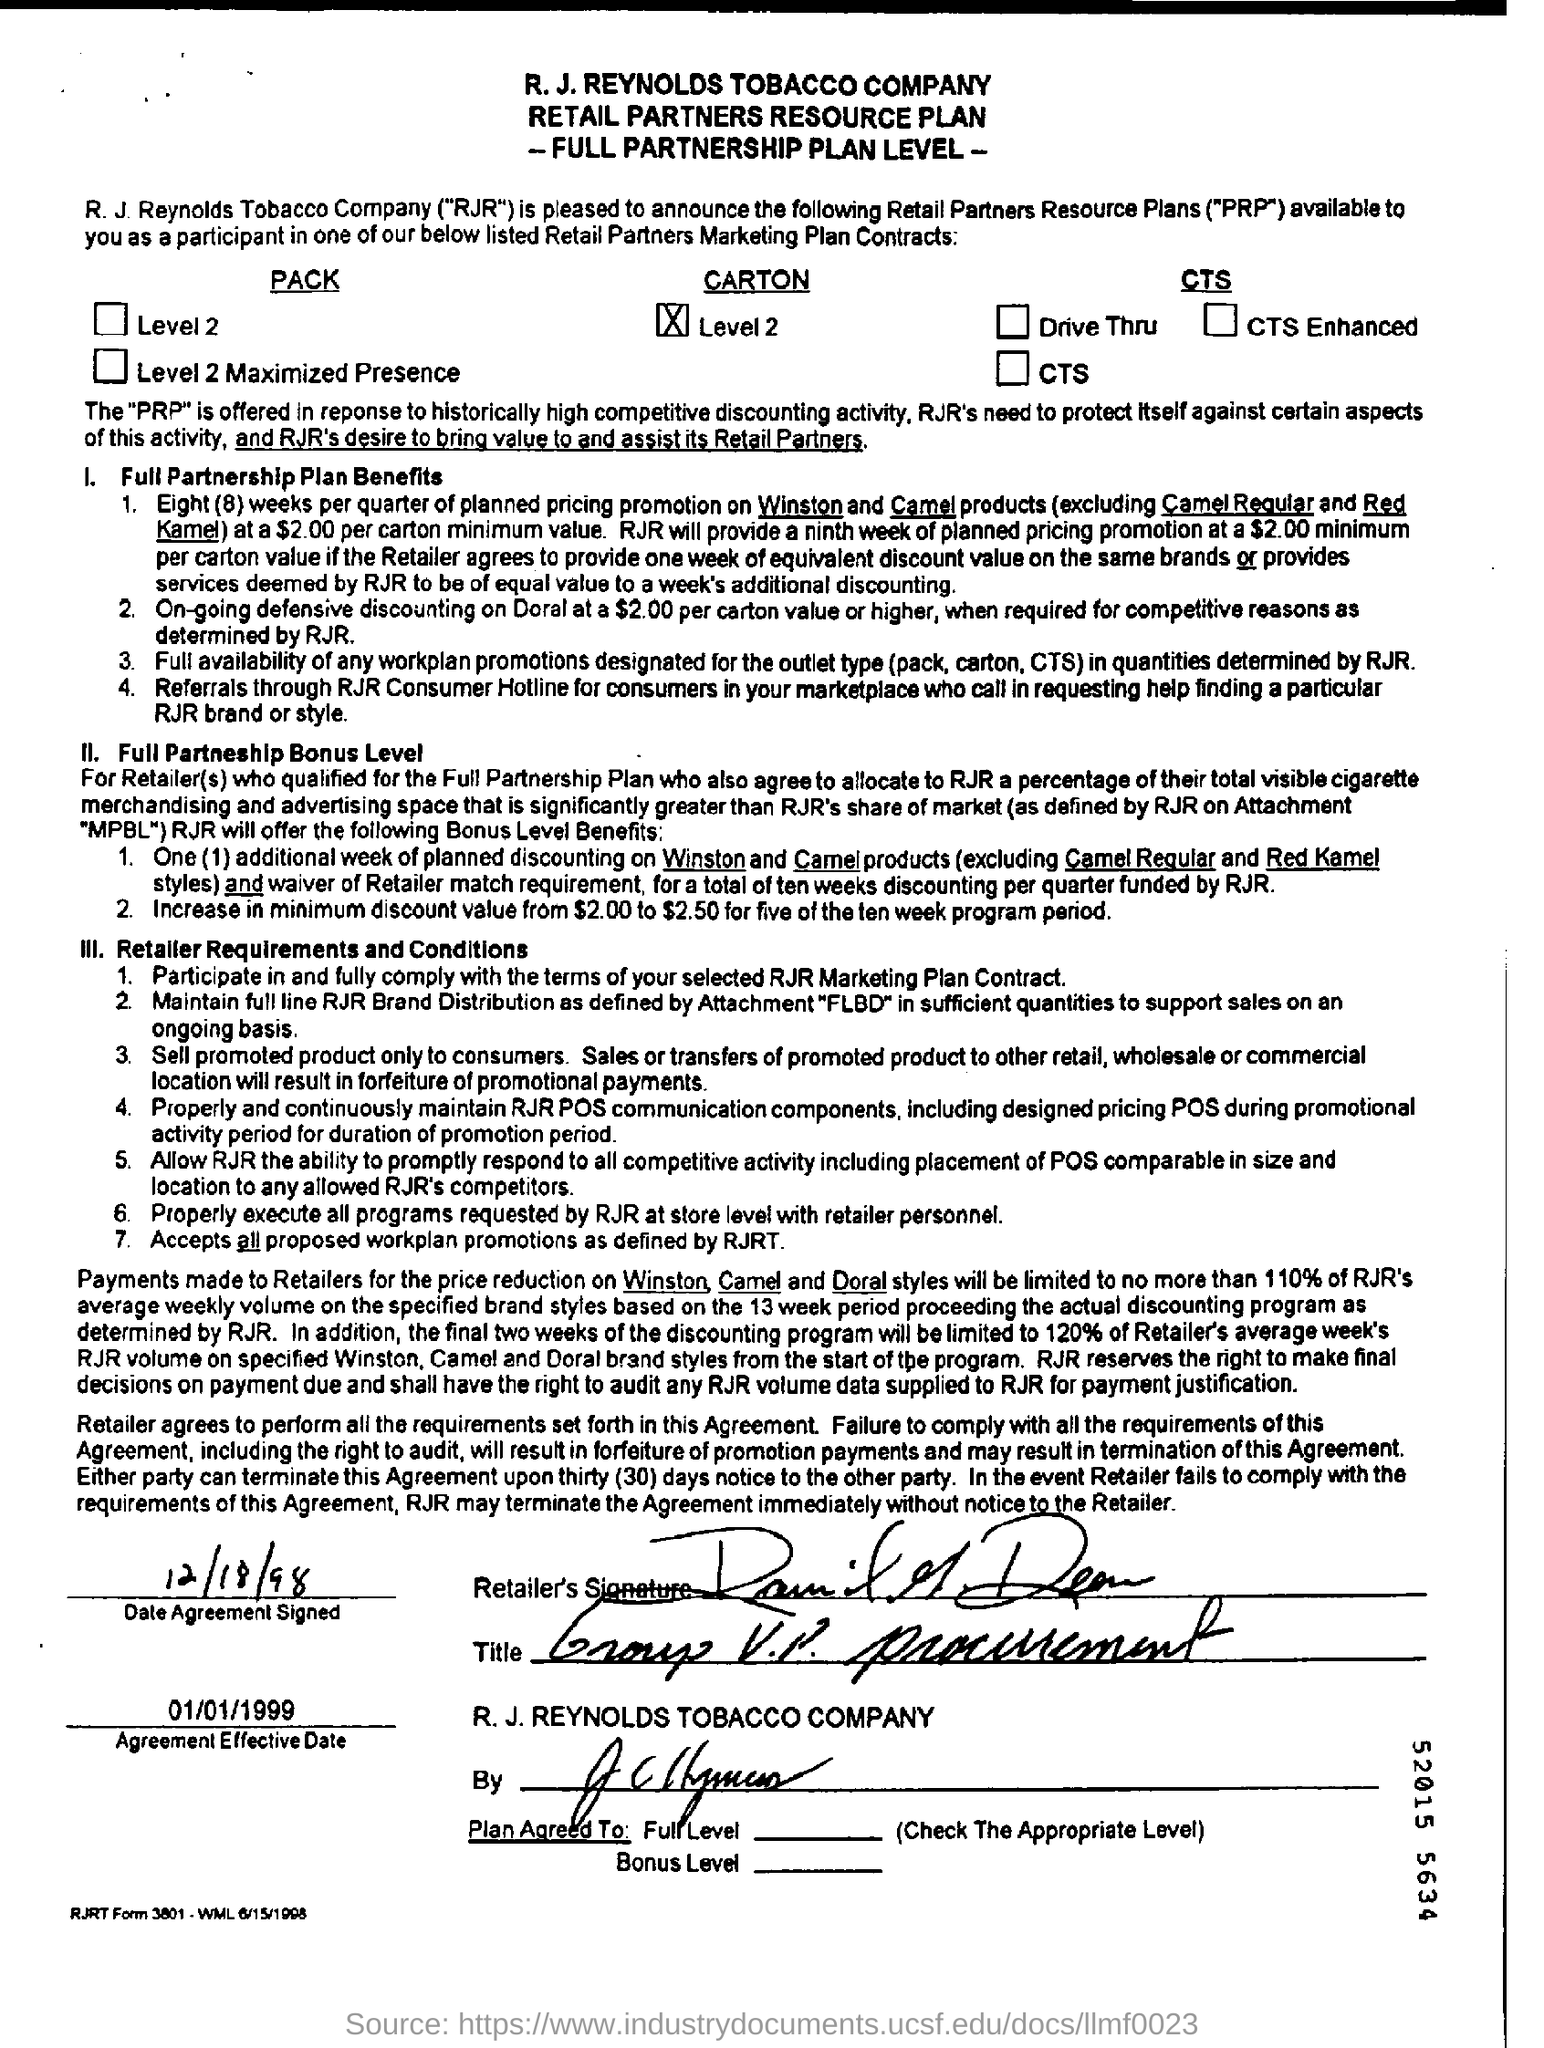Indicate a few pertinent items in this graphic. The agreement became effective on January 1, 1999. The agreement was signed on December 18, 1998. 